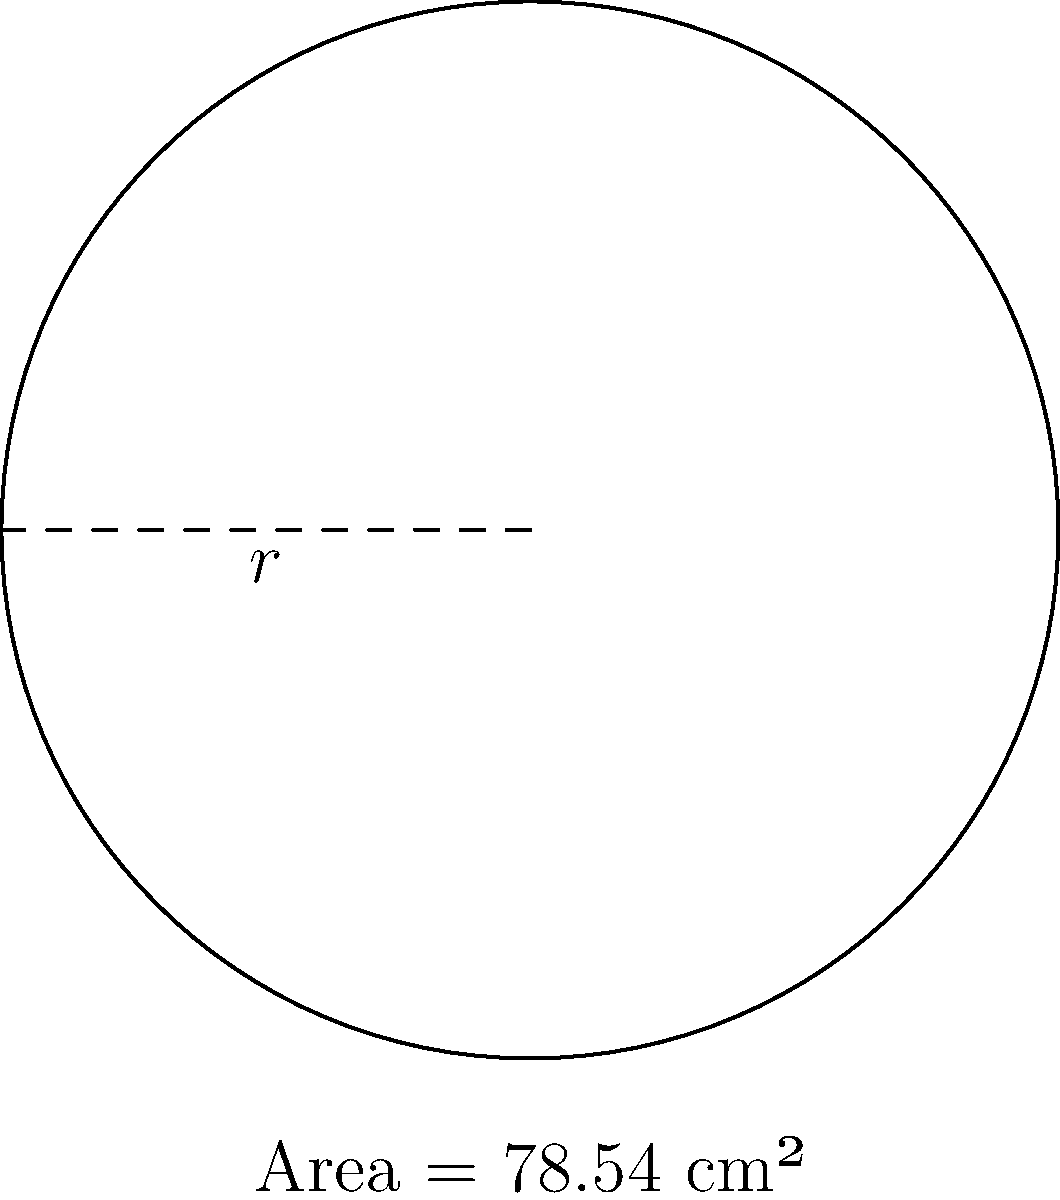As a fitness trainer developing healthier pastry options, you're designing a circular plate for portion control. If the plate has an area of 78.54 cm², what is its radius? Round your answer to the nearest centimeter. To find the radius of a circular plate when given its area, we can use the formula for the area of a circle and solve for the radius. Here's how:

1) The formula for the area of a circle is:
   $A = \pi r^2$

2) We're given that the area is 78.54 cm². Let's substitute this into our formula:
   $78.54 = \pi r^2$

3) To solve for $r$, we need to divide both sides by $\pi$:
   $\frac{78.54}{\pi} = r^2$

4) Now, we need to take the square root of both sides:
   $r = \sqrt{\frac{78.54}{\pi}}$

5) Let's calculate this:
   $r = \sqrt{\frac{78.54}{3.14159...}} \approx 5.00 \text{ cm}$

6) Rounding to the nearest centimeter:
   $r \approx 5 \text{ cm}$

This radius would create a plate with an appropriate portion size for healthier pastry servings.
Answer: 5 cm 